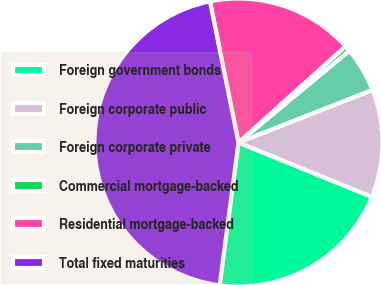<chart> <loc_0><loc_0><loc_500><loc_500><pie_chart><fcel>Foreign government bonds<fcel>Foreign corporate public<fcel>Foreign corporate private<fcel>Commercial mortgage-backed<fcel>Residential mortgage-backed<fcel>Total fixed maturities<nl><fcel>20.93%<fcel>12.11%<fcel>5.05%<fcel>0.64%<fcel>16.52%<fcel>44.74%<nl></chart> 